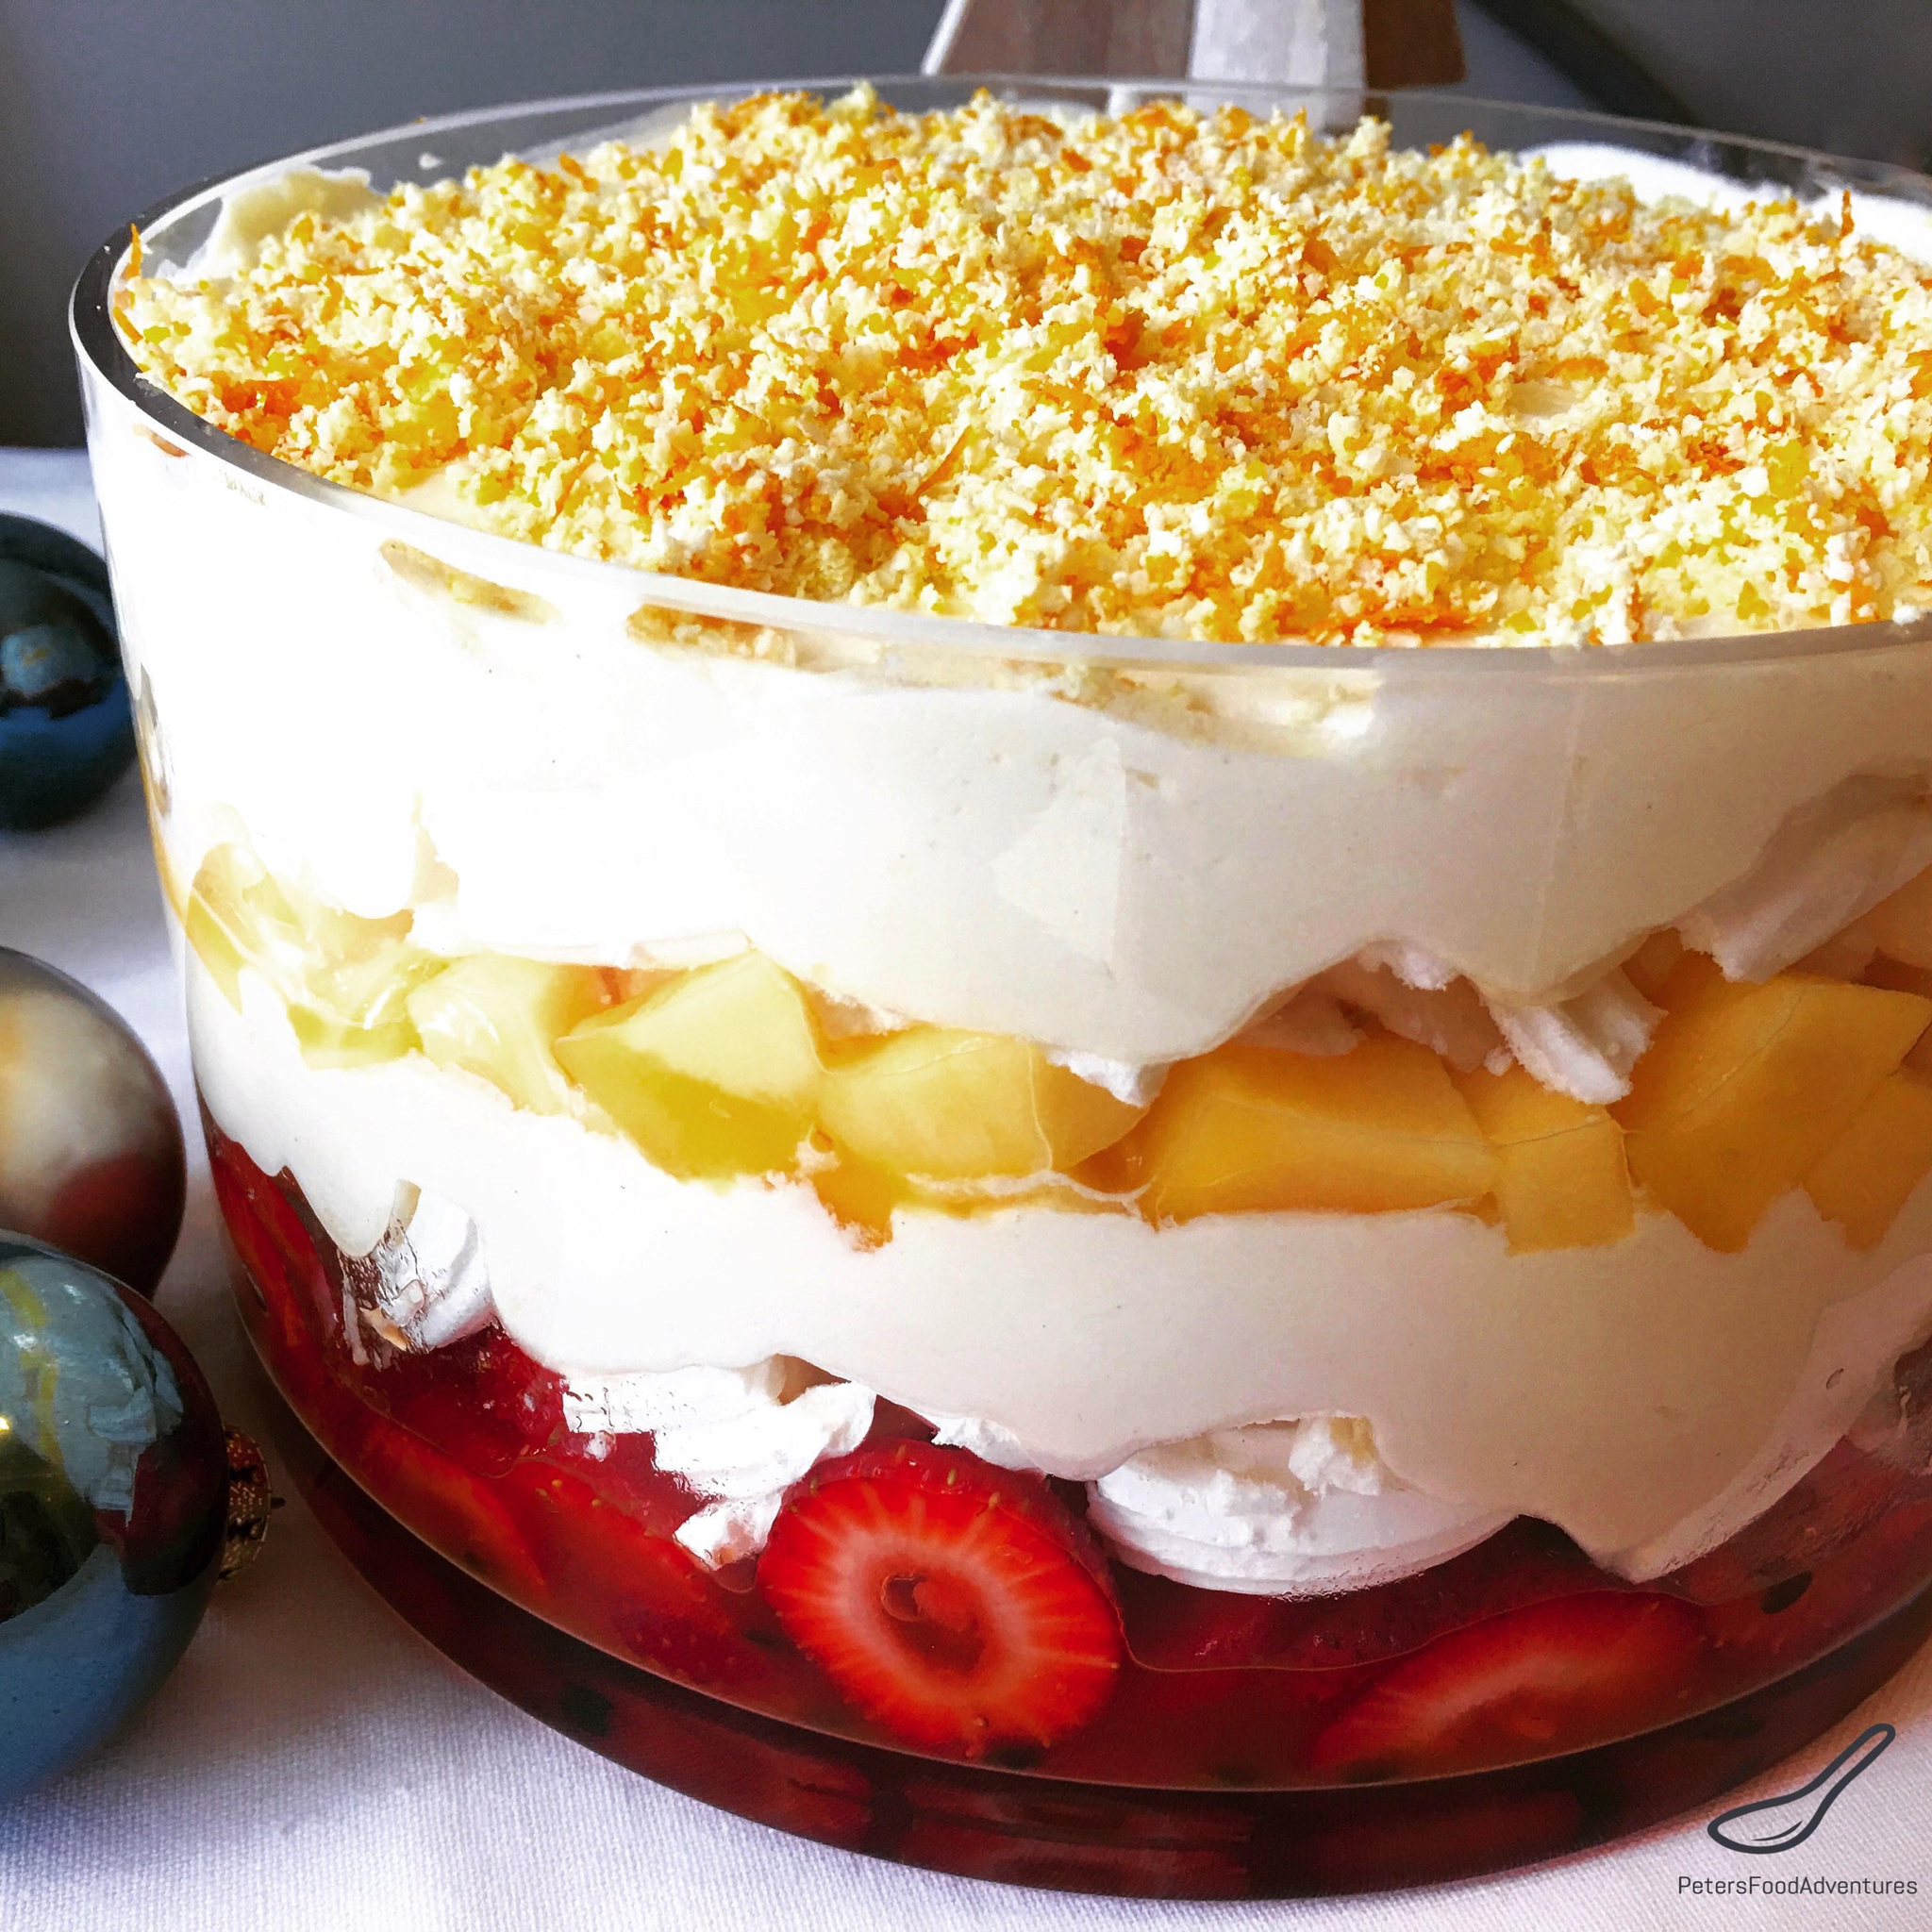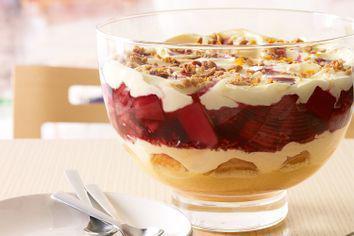The first image is the image on the left, the second image is the image on the right. Given the left and right images, does the statement "An image shows just one dessert bowl, topped with blueberries and strawberries." hold true? Answer yes or no. No. 